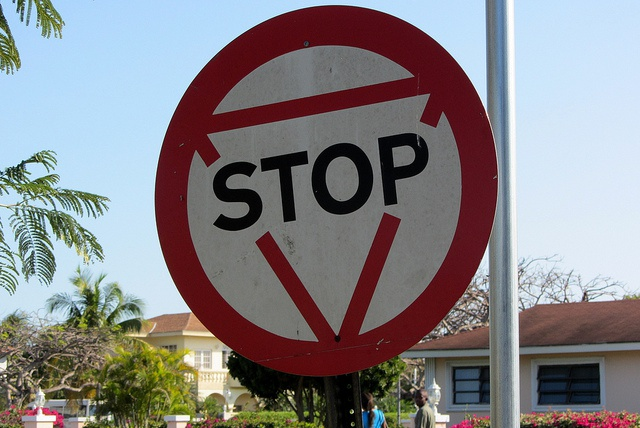Describe the objects in this image and their specific colors. I can see stop sign in lightblue, gray, maroon, and black tones, people in lightblue, black, blue, and gray tones, and people in lightblue, black, darkgray, gray, and beige tones in this image. 